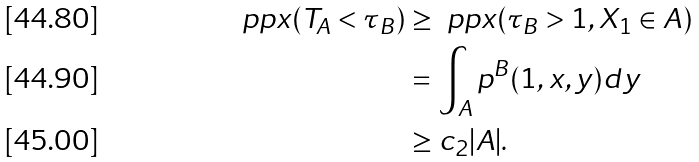Convert formula to latex. <formula><loc_0><loc_0><loc_500><loc_500>\ p p x ( T _ { A } < \tau _ { B } ) & \geq \ p p x ( \tau _ { B } > 1 , X _ { 1 } \in A ) \\ & = \int _ { A } p ^ { B } ( 1 , x , y ) d y \\ & \geq c _ { 2 } | A | .</formula> 